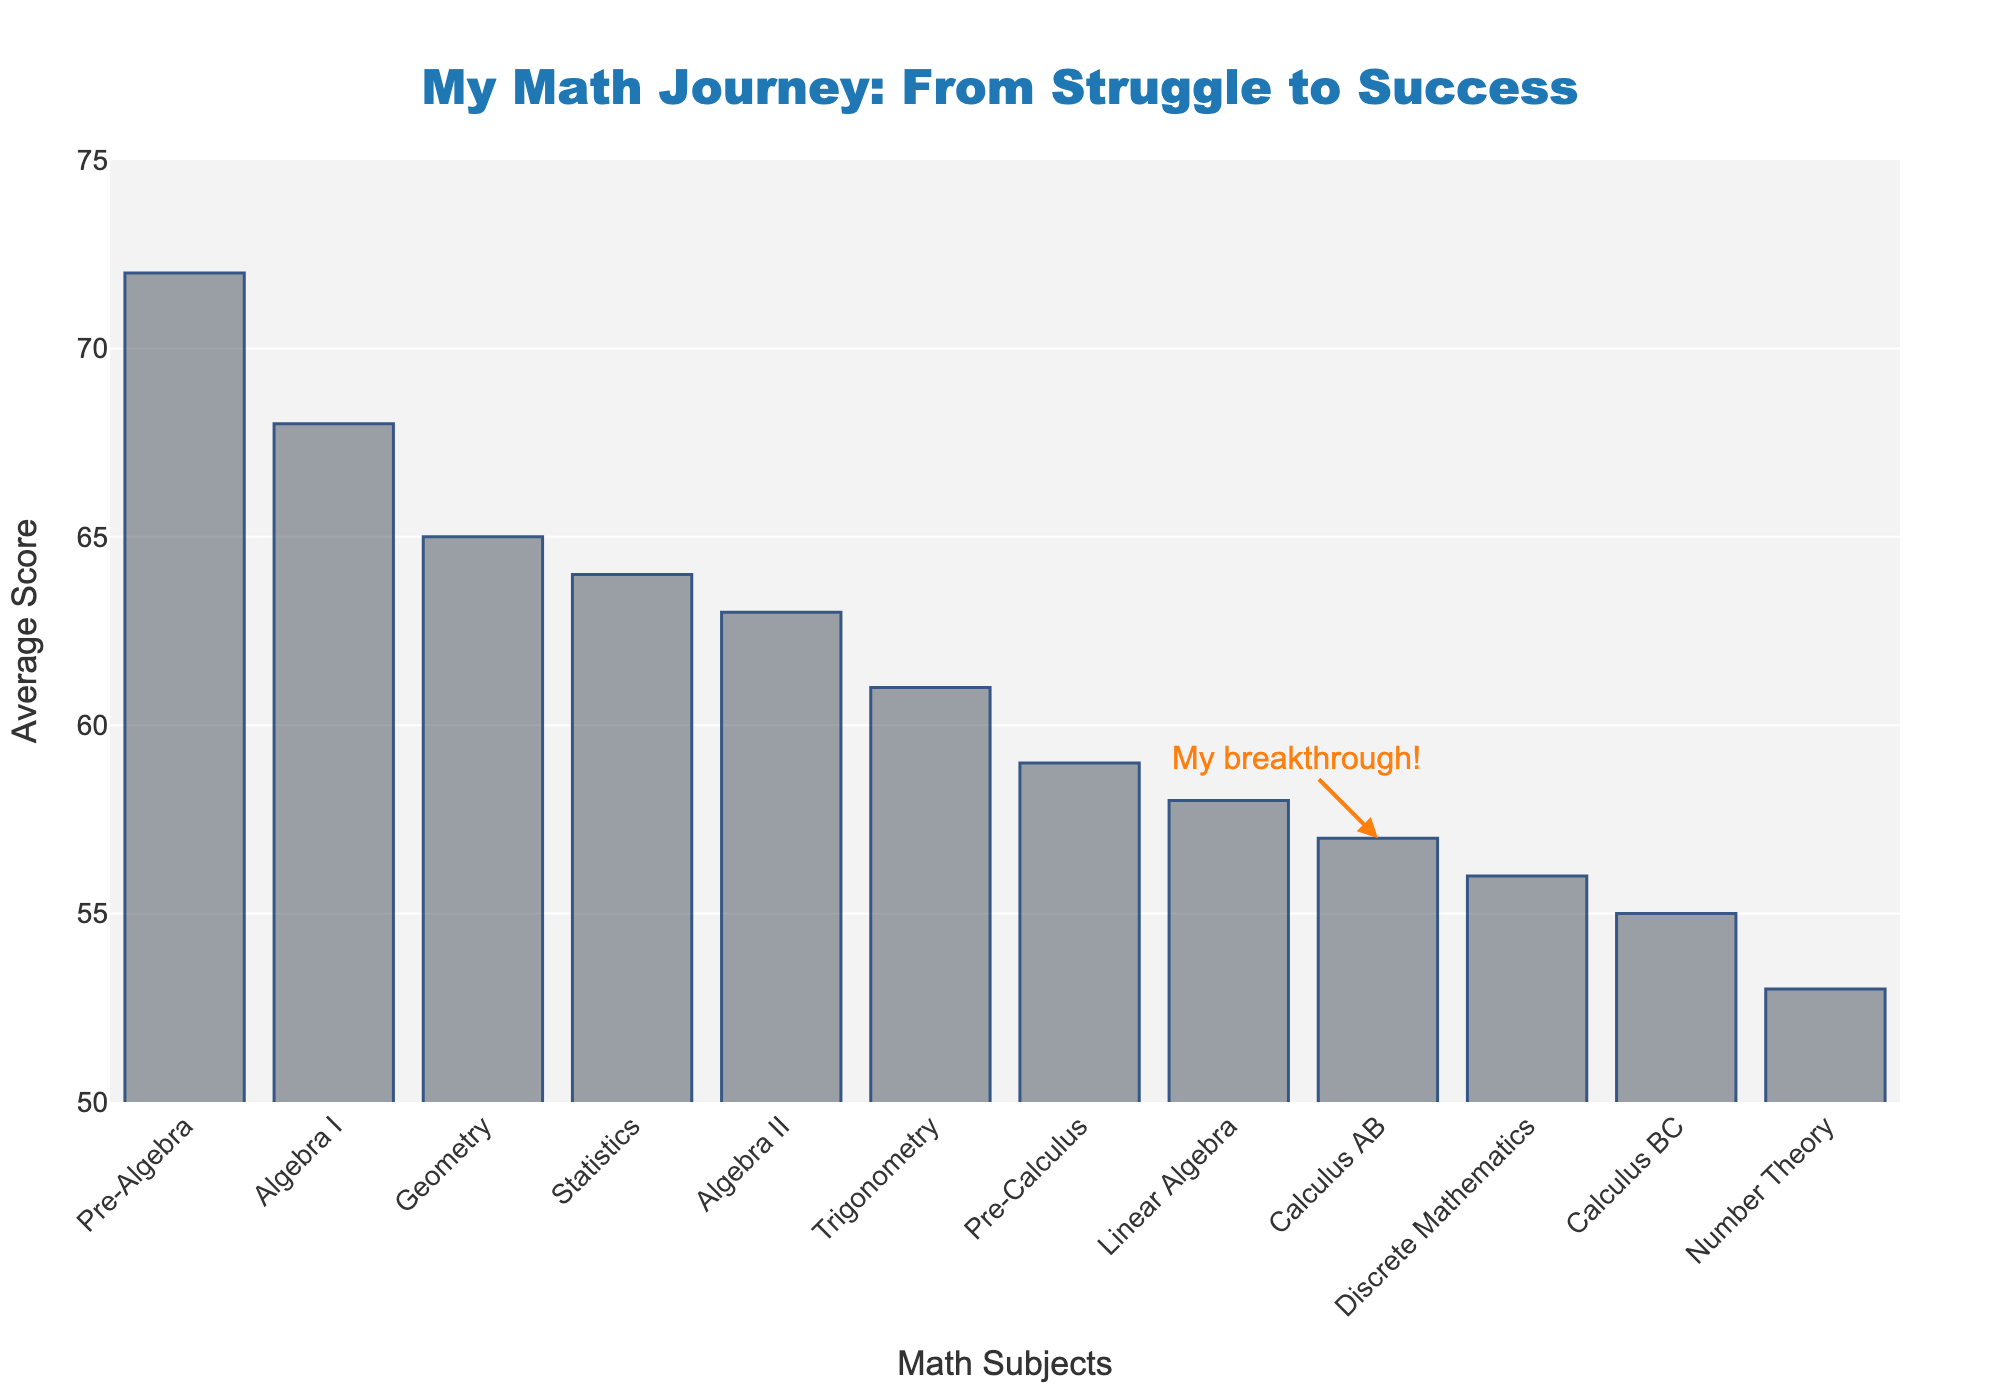Which math subject has the highest average score? The subject with the highest average score is identified by the tallest bar in the figure, representing Pre-Algebra, having the highest value of 72.
Answer: Pre-Algebra Which math subject has the lowest average score? The subject with the lowest average score is identified by the shortest bar in the figure, representing Number Theory, having the lowest value of 53.
Answer: Number Theory What is the difference in average scores between the highest and lowest scoring subjects? Calculate the difference in average scores by subtracting the value of the lowest scoring subject (Number Theory, 53) from the highest scoring subject (Pre-Algebra, 72). 72 - 53 = 19.
Answer: 19 How does the average score of Statistics compare with Pre-Calculus? By comparing the heights of the bars representing Statistics (64) and Pre-Calculus (59), we see that Statistics has a higher average score than Pre-Calculus.
Answer: Statistics has a higher score What is the trend in average scores as you move from Pre-Algebra to Number Theory? As you move from Pre-Algebra to Number Theory, the height of the bars generally decreases, indicating that the average scores decline.
Answer: Scores decrease By how many points does the average score of Trigonometry exceed that of Discrete Mathematics? The average score of Trigonometry is 61, and Discrete Mathematics is 56. Subtract the average score of Discrete Mathematics from Trigonometry: 61 - 56 = 5.
Answer: 5 What is the average score of the calculus subjects (Calculus AB and Calculus BC)? Add the average scores of Calculus AB (57) and Calculus BC (55), and then divide by the number of subjects: (57 + 55) / 2 = 56.
Answer: 56 Which subject is marked with an annotation indicating a breakthrough? The bar for Calculus AB is marked with an annotation indicating "My breakthrough!".
Answer: Calculus AB 